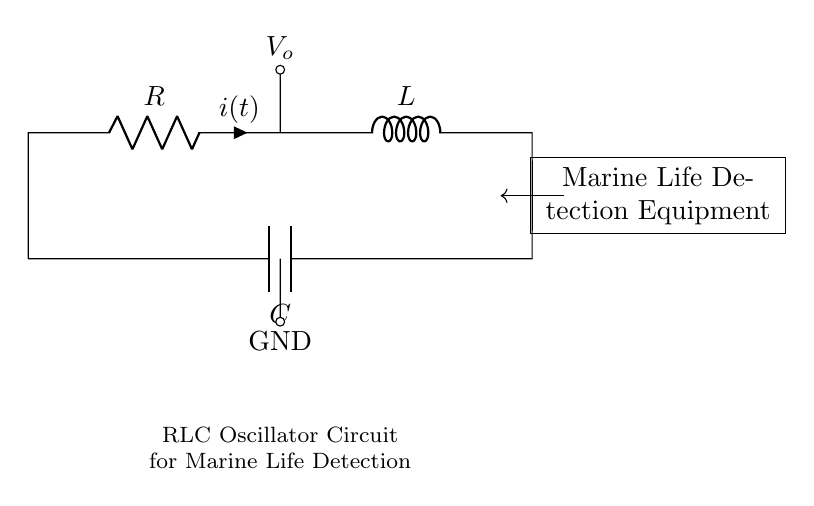What components are in this circuit? The circuit consists of a resistor, inductor, and capacitor, which are indicated by their symbols and labeled accordingly.
Answer: resistor, inductor, capacitor What is the output voltage indicated in the circuit? The output voltage is labeled as  V_o, which signifies where the output can be measured in relation to the other circuit elements.
Answer: V_o Which component is connected to the ground? The capacitor is the only component connected to the ground in this diagram, as indicated by the grounding symbol seen at the bottom connection of the circuit.
Answer: capacitor Which components form the oscillatory behavior in an RLC circuit? The combination of the resistor, inductor, and capacitor together contributes to the oscillatory behavior, where the inductor and capacitor exchange energy, leading to oscillations.
Answer: inductor and capacitor What is the purpose of this RLC circuit? The circuit is designated for marine life detection equipment, which implies that it is used to emit or detect signals to observe underwater life.
Answer: marine life detection How are components connected in this circuit? The resistor is in series with the inductor while the capacitor is connected in parallel with the combination of the resistor and inductor, forming a closed loop circuit.
Answer: series and parallel What role does the inductor play in this RLC circuit? The inductor stores energy in a magnetic field and is responsible for determining the resonant frequency of the circuit, thus influencing its oscillatory performance.
Answer: energy storage and frequency determination 